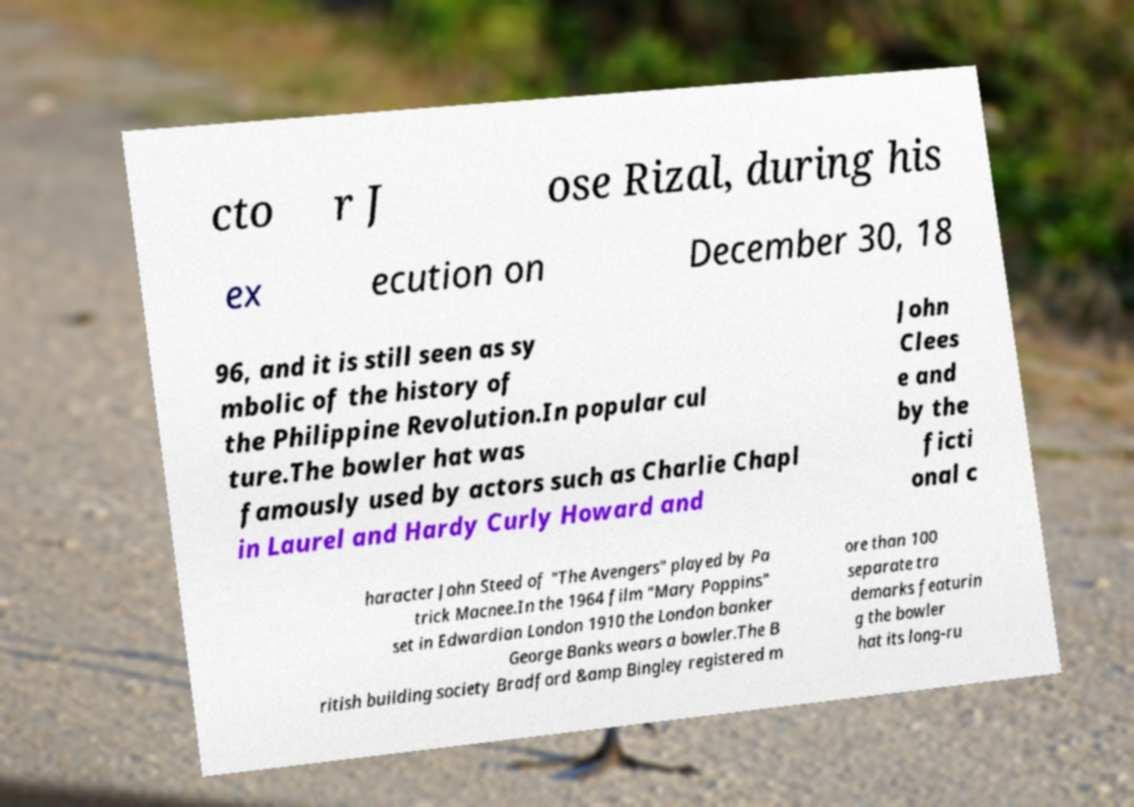Please identify and transcribe the text found in this image. cto r J ose Rizal, during his ex ecution on December 30, 18 96, and it is still seen as sy mbolic of the history of the Philippine Revolution.In popular cul ture.The bowler hat was famously used by actors such as Charlie Chapl in Laurel and Hardy Curly Howard and John Clees e and by the ficti onal c haracter John Steed of "The Avengers" played by Pa trick Macnee.In the 1964 film "Mary Poppins" set in Edwardian London 1910 the London banker George Banks wears a bowler.The B ritish building society Bradford &amp Bingley registered m ore than 100 separate tra demarks featurin g the bowler hat its long-ru 